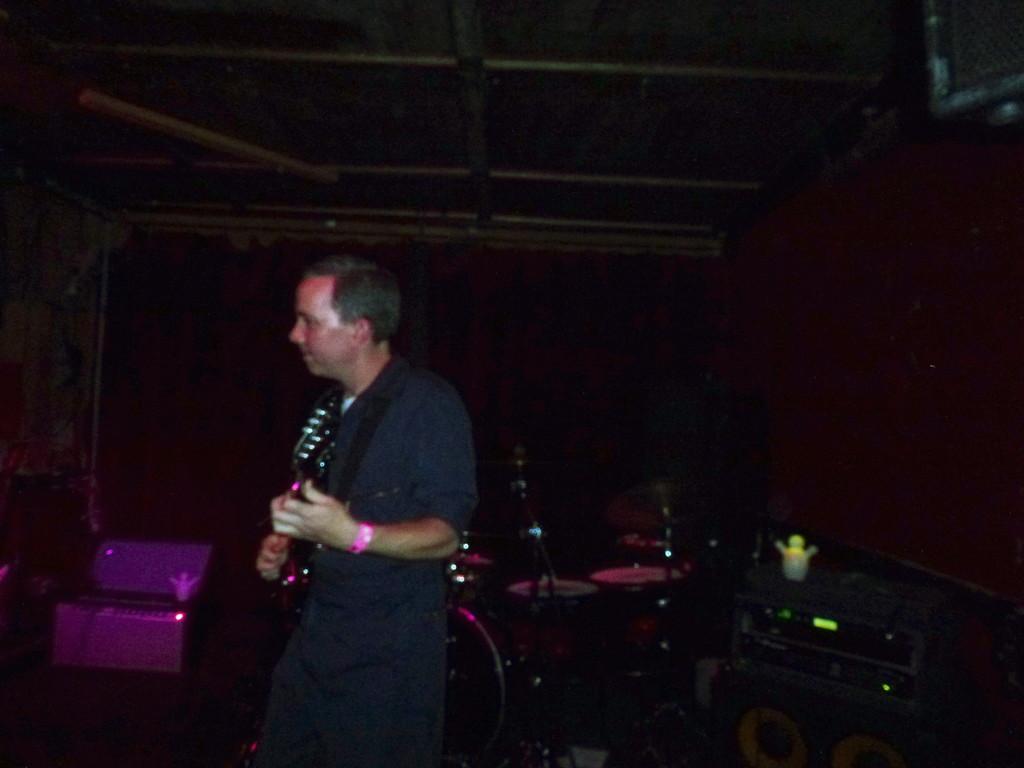Can you describe this image briefly? In the image we can see a man standing, wearing clothes and holding a guitar in hand. Here we can see musical instruments and the background is dark 